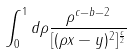Convert formula to latex. <formula><loc_0><loc_0><loc_500><loc_500>\int _ { 0 } ^ { 1 } d \rho \frac { \rho ^ { c - b - 2 } } { [ ( \rho x - y ) ^ { 2 } ] ^ { \frac { c } { 2 } } }</formula> 